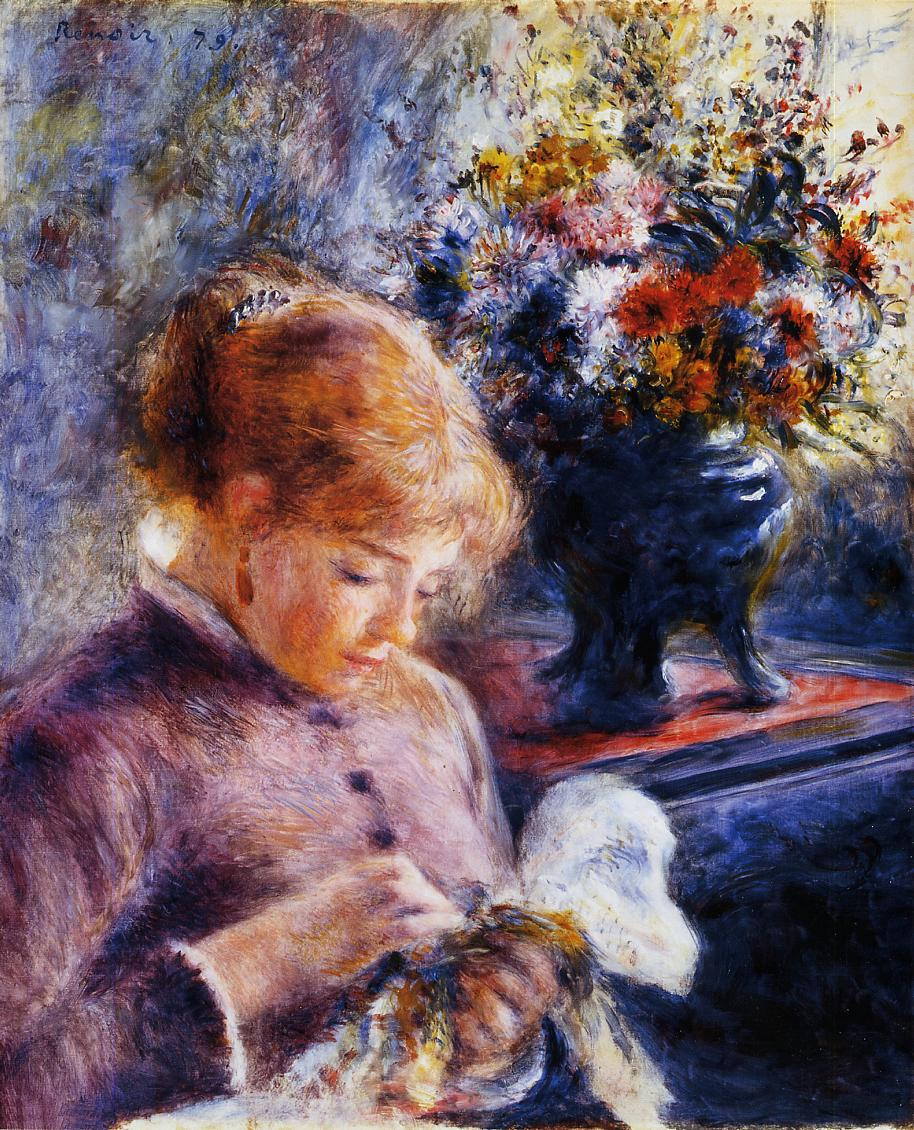What might this woman be thinking about while she is doing her needlework? As she immerses herself in her needlework, one might imagine the woman reflecting on her day, mulling over thoughts and plans, or perhaps simply enjoying the meditative rhythm of her task. She could be thinking about her loved ones, reminiscing about past events, or pondering future ambitions. The serene and focused expression on her face suggests she finds solace and joy in this quiet moment, her thoughts drifting gently along with the motion of her hands. Do you think she is creating something for someone special? It's quite possible that she is crafting something with love and care for someone close to her heart. The dedication and attention she pours into her needlework might imply a cherished relationship. Whether it's a gift for a family member, a token of affection for a friend, or a personal project, her engagement with the task suggests it holds significant importance to her. 